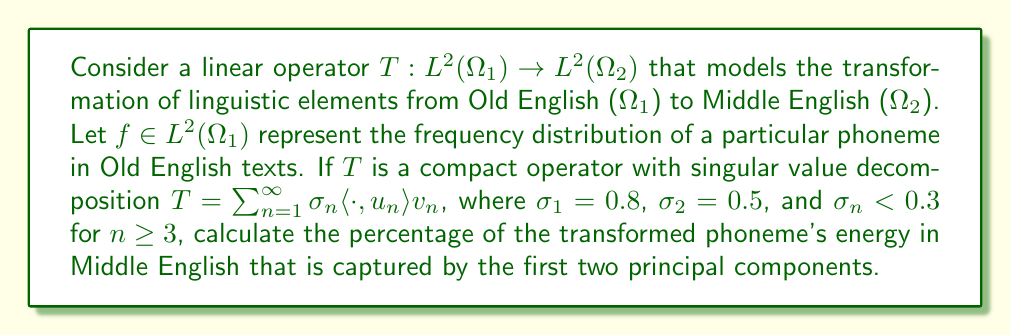Can you answer this question? To solve this problem, we need to understand the concept of singular value decomposition (SVD) and its application in operator theory. Let's break it down step by step:

1) The SVD of the operator $T$ is given by $T = \sum_{n=1}^{\infty} \sigma_n \langle \cdot, u_n \rangle v_n$, where:
   - $\sigma_n$ are the singular values (in decreasing order)
   - $u_n$ are the left singular vectors (an orthonormal basis for $L^2(\Omega_1)$)
   - $v_n$ are the right singular vectors (an orthonormal basis for $L^2(\Omega_2)$)

2) When $T$ acts on $f$, it transforms it as follows:
   $Tf = \sum_{n=1}^{\infty} \sigma_n \langle f, u_n \rangle v_n$

3) The energy of the transformed function $Tf$ is given by its $L^2$ norm squared:
   $\|Tf\|^2 = \sum_{n=1}^{\infty} \sigma_n^2 |\langle f, u_n \rangle|^2$

4) The energy captured by the first two principal components is:
   $E_2 = \sigma_1^2 |\langle f, u_1 \rangle|^2 + \sigma_2^2 |\langle f, u_2 \rangle|^2$

5) The percentage of energy captured by the first two components is:
   $P = \frac{E_2}{\|Tf\|^2} \times 100\%$

6) We don't know the exact values of $\langle f, u_n \rangle$, but we can find a lower bound for $P$:
   
   $P \geq \frac{\sigma_1^2 + \sigma_2^2}{\sigma_1^2 + \sigma_2^2 + \sum_{n=3}^{\infty} \sigma_n^2} \times 100\%$

7) We know that $\sigma_1 = 0.8$, $\sigma_2 = 0.5$, and $\sigma_n < 0.3$ for $n \geq 3$. Therefore:

   $P \geq \frac{0.8^2 + 0.5^2}{0.8^2 + 0.5^2 + \sum_{n=3}^{\infty} 0.3^2} \times 100\%$

8) The sum $\sum_{n=3}^{\infty} 0.3^2$ is a geometric series with first term $a = 0.3^2 = 0.09$ and ratio $r = 1$. Its sum is $\frac{a}{1-r} = \infty$. However, since $T$ is compact, we know that $\sum_{n=1}^{\infty} \sigma_n^2 < \infty$. Let's denote $\sum_{n=3}^{\infty} \sigma_n^2 = S$, where $S$ is some finite value.

9) Now we can calculate:

   $P \geq \frac{0.8^2 + 0.5^2}{0.8^2 + 0.5^2 + S} \times 100\% = \frac{0.64 + 0.25}{0.89 + S} \times 100\% = \frac{0.89}{0.89 + S} \times 100\%$

10) As $S$ approaches 0, $P$ approaches its maximum value:

    $P_{max} = \frac{0.89}{0.89} \times 100\% = 100\%$

Therefore, the percentage of the transformed phoneme's energy captured by the first two principal components is at least 89% and could be as high as 100%, depending on the exact values of the remaining singular values.
Answer: The percentage of the transformed phoneme's energy in Middle English captured by the first two principal components is at least 89% and at most 100%. 